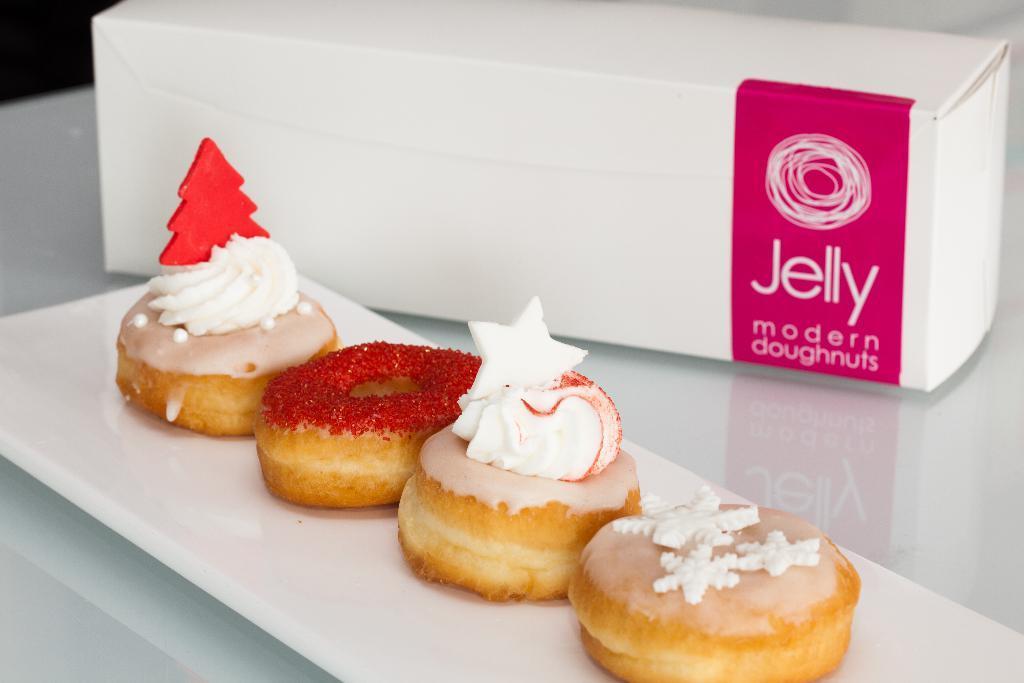Could you give a brief overview of what you see in this image? In this picture we can see four doughnuts on a white tray, box and these two are placed on a platform. 